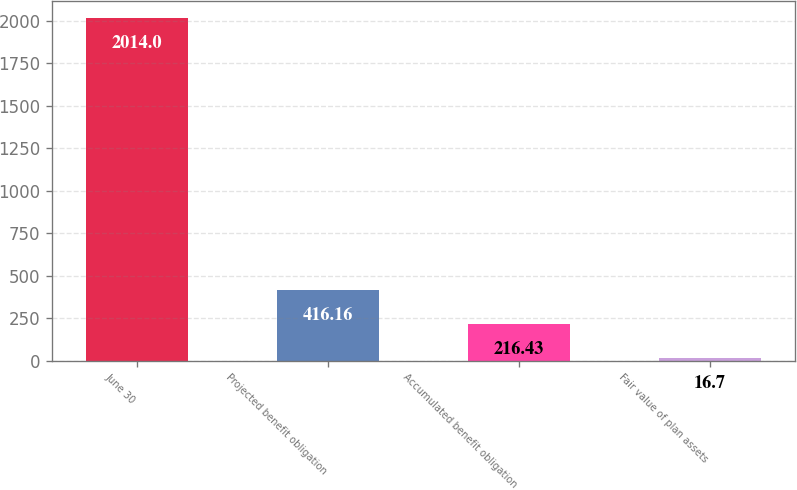<chart> <loc_0><loc_0><loc_500><loc_500><bar_chart><fcel>June 30<fcel>Projected benefit obligation<fcel>Accumulated benefit obligation<fcel>Fair value of plan assets<nl><fcel>2014<fcel>416.16<fcel>216.43<fcel>16.7<nl></chart> 